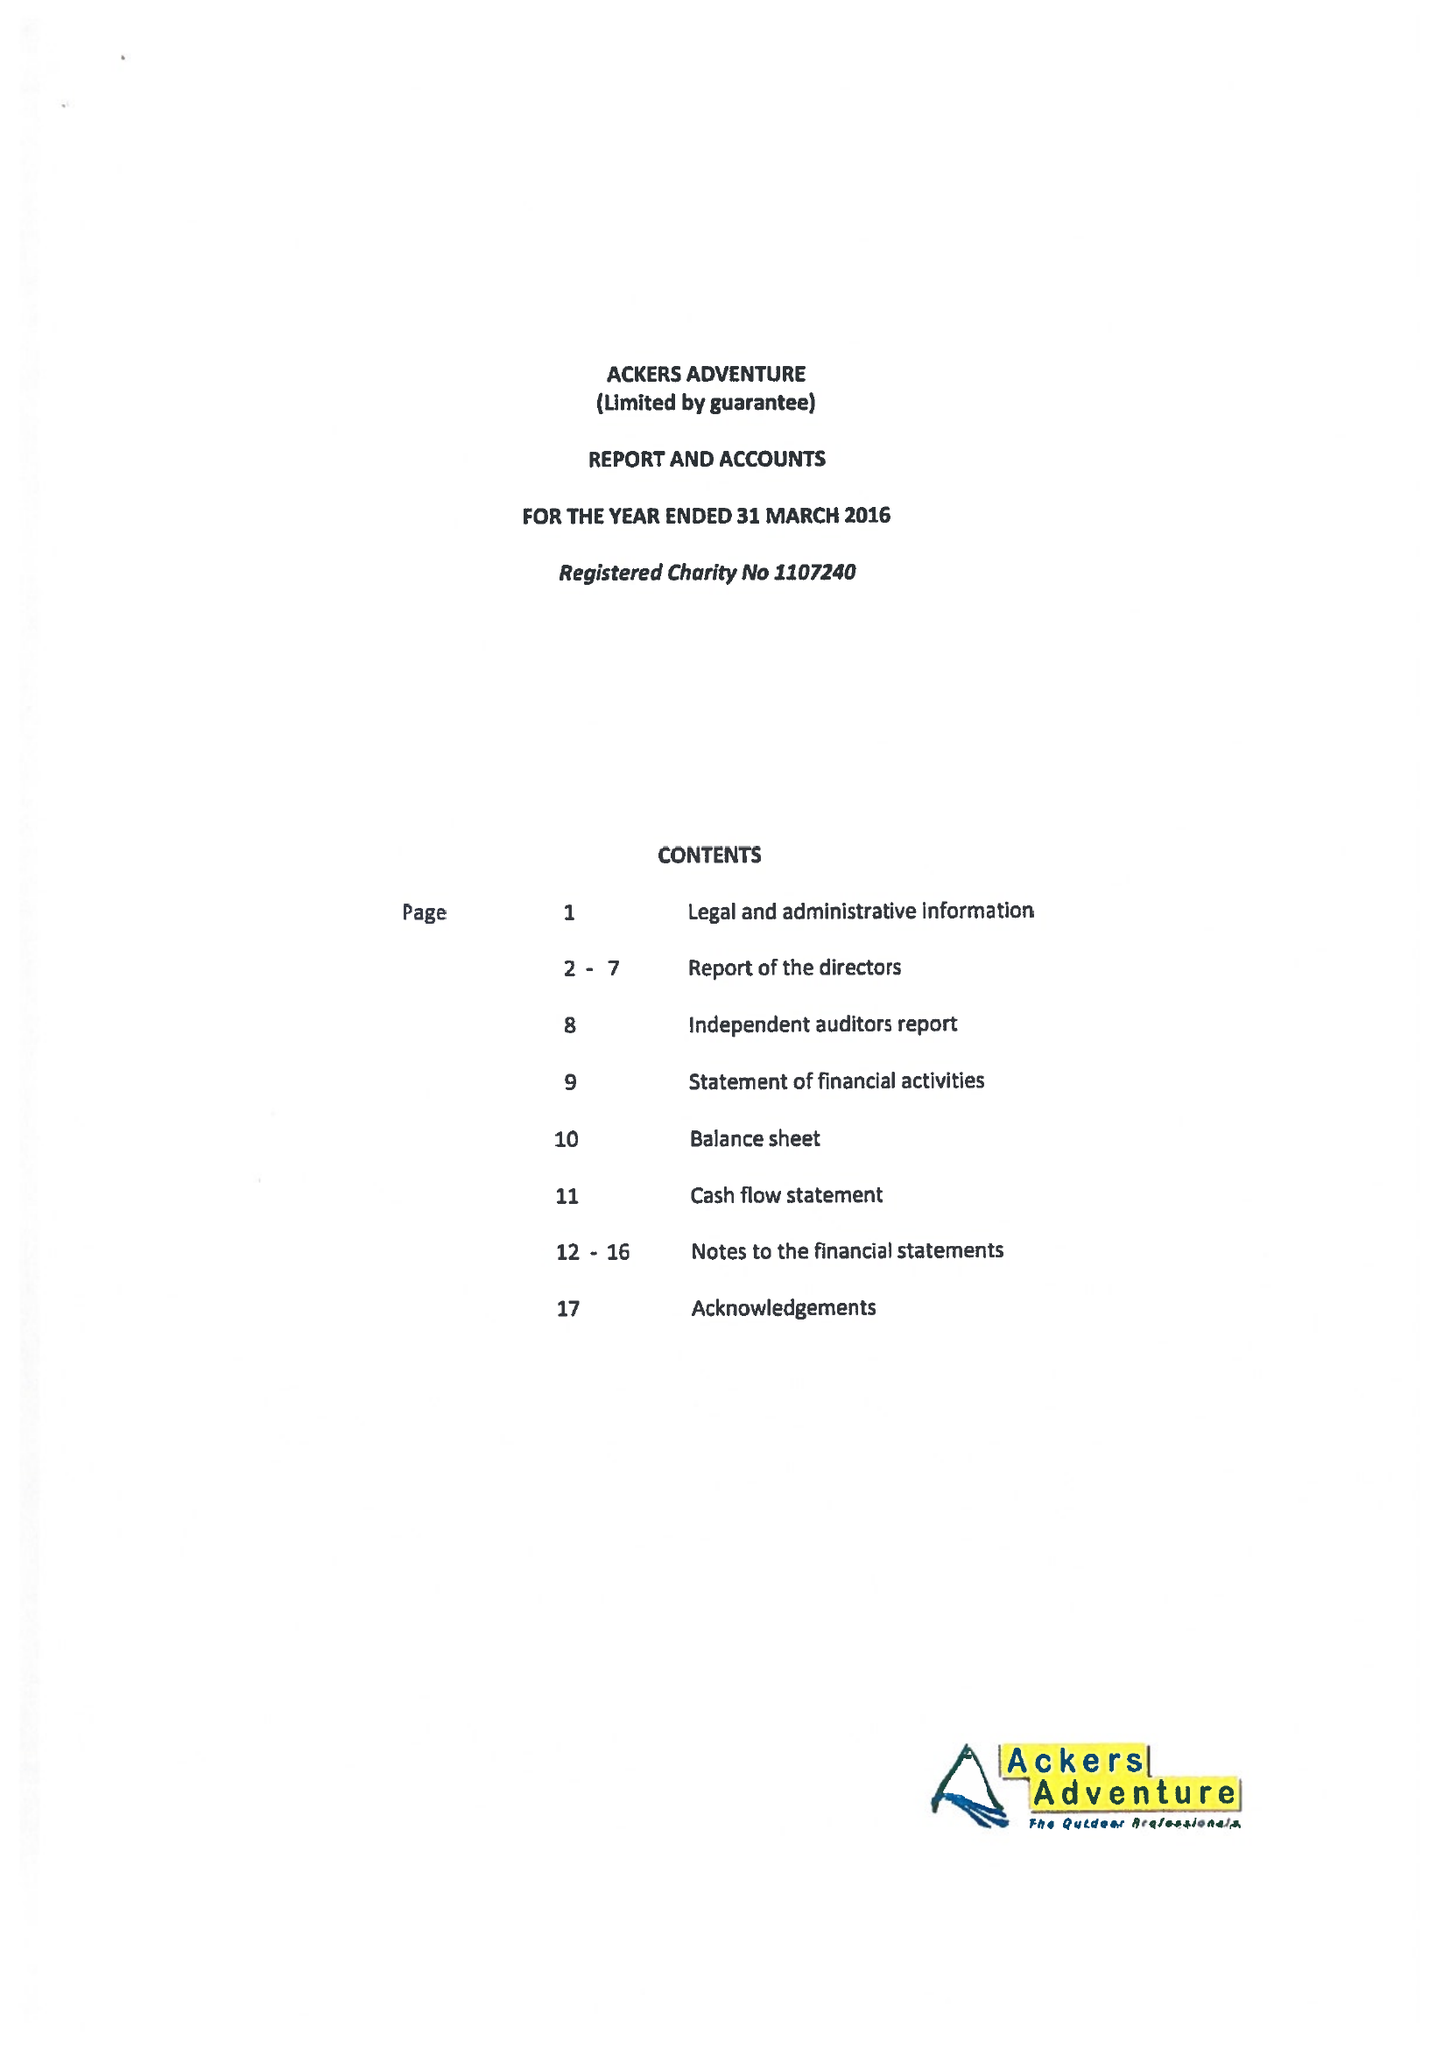What is the value for the address__post_town?
Answer the question using a single word or phrase. BIRMINGHAM 